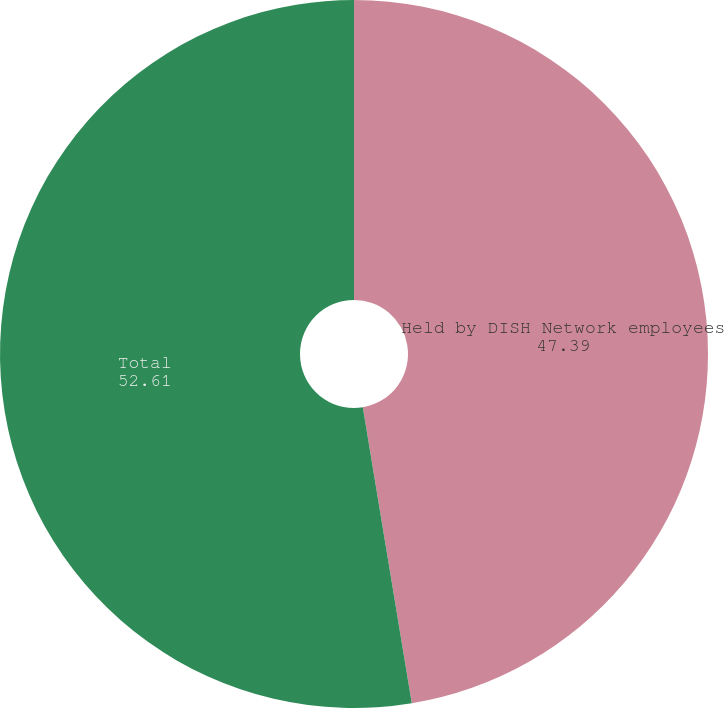<chart> <loc_0><loc_0><loc_500><loc_500><pie_chart><fcel>Held by DISH Network employees<fcel>Total<nl><fcel>47.39%<fcel>52.61%<nl></chart> 